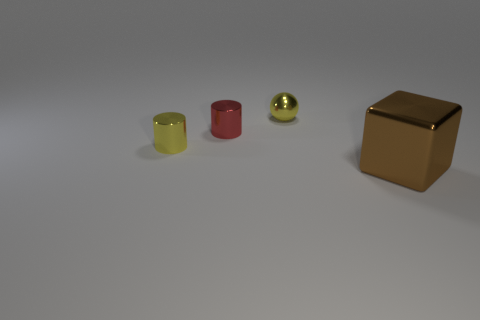Add 2 cubes. How many objects exist? 6 Subtract all cubes. How many objects are left? 3 Add 3 large metal things. How many large metal things are left? 4 Add 2 big brown metal things. How many big brown metal things exist? 3 Subtract 0 green blocks. How many objects are left? 4 Subtract all brown matte objects. Subtract all small red metal cylinders. How many objects are left? 3 